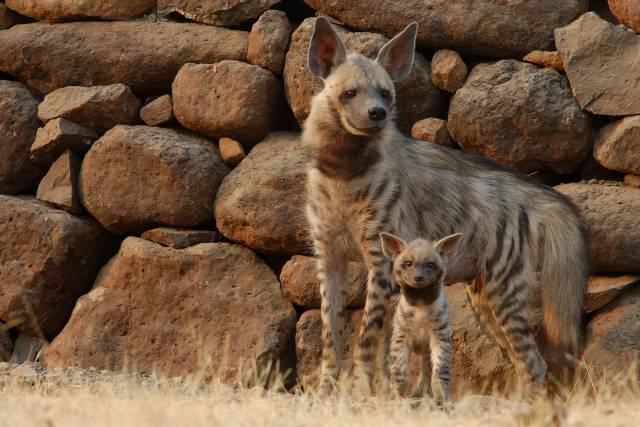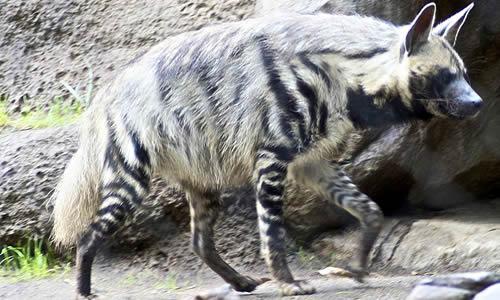The first image is the image on the left, the second image is the image on the right. For the images shown, is this caption "There is one baby hyena." true? Answer yes or no. Yes. The first image is the image on the left, the second image is the image on the right. Considering the images on both sides, is "there are at least three hyenas in the image on the left" valid? Answer yes or no. No. 